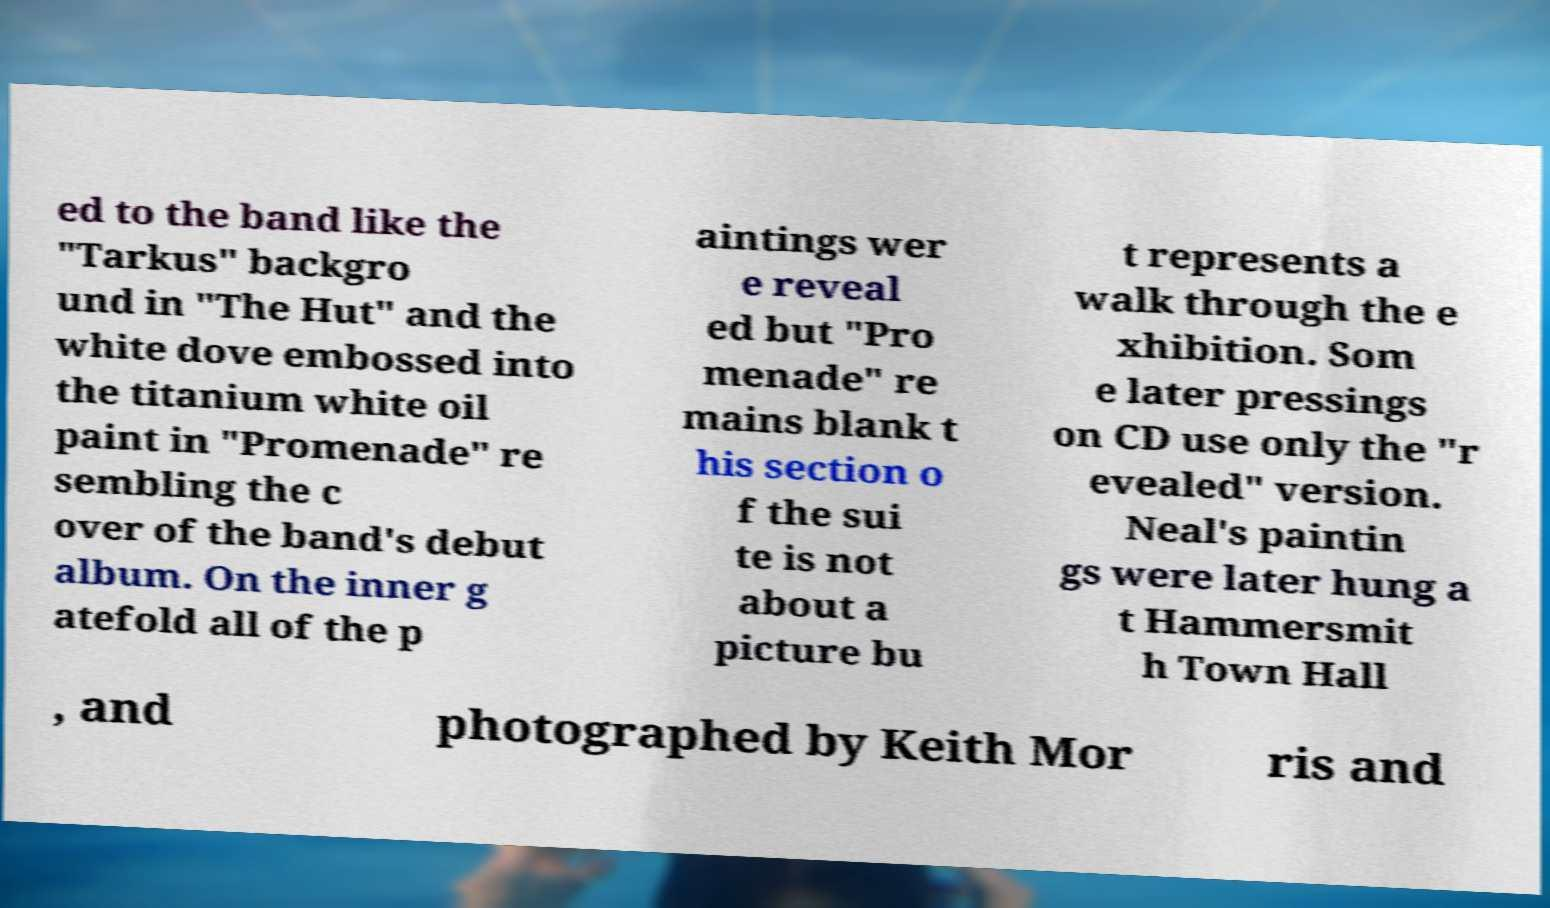Can you accurately transcribe the text from the provided image for me? ed to the band like the "Tarkus" backgro und in "The Hut" and the white dove embossed into the titanium white oil paint in "Promenade" re sembling the c over of the band's debut album. On the inner g atefold all of the p aintings wer e reveal ed but "Pro menade" re mains blank t his section o f the sui te is not about a picture bu t represents a walk through the e xhibition. Som e later pressings on CD use only the "r evealed" version. Neal's paintin gs were later hung a t Hammersmit h Town Hall , and photographed by Keith Mor ris and 